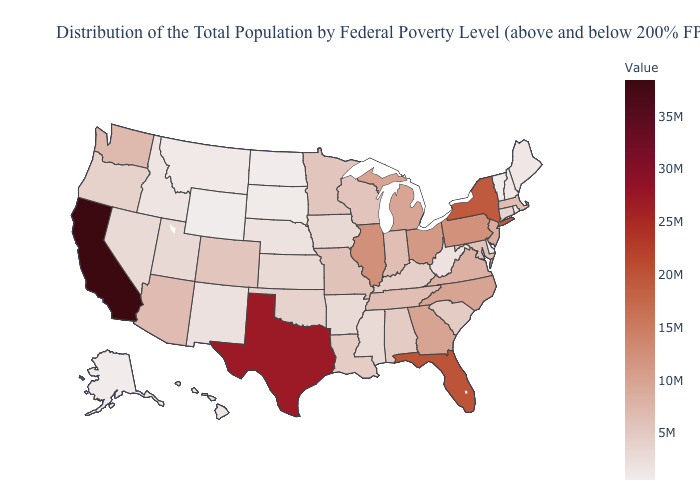Which states have the lowest value in the USA?
Write a very short answer. Wyoming. Which states have the highest value in the USA?
Short answer required. California. Among the states that border Missouri , which have the highest value?
Be succinct. Illinois. Among the states that border Oregon , which have the lowest value?
Answer briefly. Idaho. Does Arizona have a higher value than Illinois?
Keep it brief. No. 